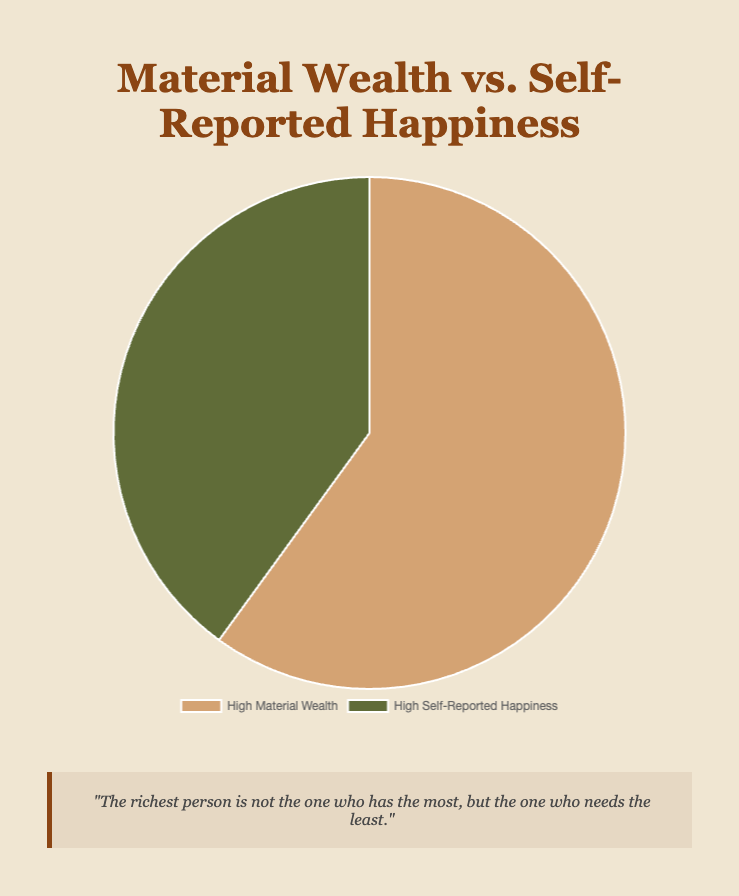What percentage of individuals report high self-reported happiness? The figure shows two categories: High Material Wealth with 60% and High Self-Reported Happiness with 40%. We look at the second category to get the percentage.
Answer: 40% Which group comprises a larger proportion of the population: those with high material wealth or those with high self-reported happiness? Comparing the percentages, High Material Wealth has 60%, while High Self-Reported Happiness has 40%. The former is larger.
Answer: High Material Wealth How much larger is the percentage of high material wealth compared to high self-reported happiness? To find the difference between the two percentages: 60% (High Material Wealth) - 40% (High Self-Reported Happiness) = 20%.
Answer: 20% If you combine both categories, what is the total percentage represented in the chart? Adding both percentages, 60% (High Material Wealth) + 40% (High Self-Reported Happiness) = 100%.
Answer: 100% What color represents individuals with high self-reported happiness in the chart? According to the legend in the chart, High Self-Reported Happiness is represented by the green segment.
Answer: Green Based on the proportions shown, can it be inferred that the majority of the population falls into the High Self-Reported Happiness category? Since High Material Wealth (60%) makes up more of the chart than High Self-Reported Happiness (40%), it can be inferred that the majority is in the High Material Wealth category.
Answer: No What percentage of individuals with high material wealth also report high self-reported happiness, assuming no overlap? Since the given data shows percentages for separate groups and no overlap is indicated, individuals with high material wealth who also report high happiness would be not represented in this dataset.
Answer: No data If an individual's self-reported happiness level is low, what might be their likelihood of having high material wealth based on the pie chart? The figure indicates that 60% have High Material Wealth, implying some proportion of individuals with low happiness may still have high material wealth, though specific data is not given.
Answer: Likely How does the psychological quote relate to the data shown in the pie chart? The quote, "The richest person is not the one who has the most, but the one who needs the least," suggests true happiness isn't necessarily tied to material wealth. This mirrors the chart where a significant portion (40%) reports high happiness independent of material wealth.
Answer: Suggests happiness isn't tied to wealth 